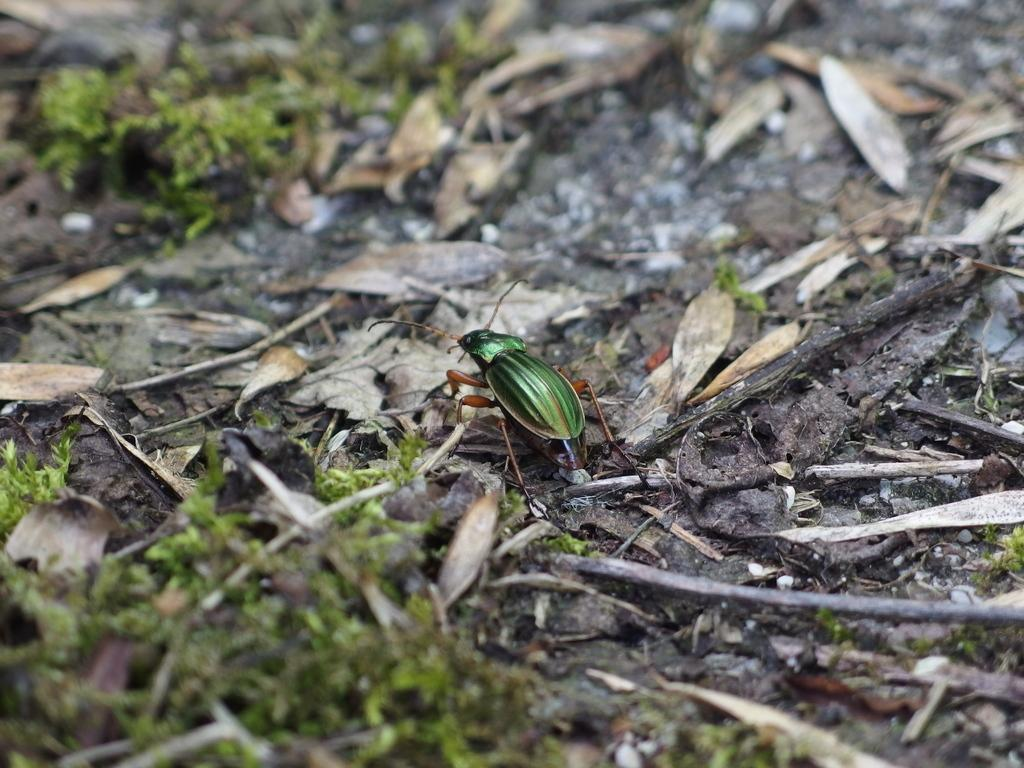What type of creature can be seen on the leaves in the image? There is an insect on the leaves in the image. What is the condition of the leaves in the image? The leaves are on the ground in the image. What other objects can be seen on the ground in the image? There are sticks and grass on the ground in the image. Reasoning: Let'g: Let's think step by step in order to produce the conversation. We start by identifying the main subject in the image, which is the insect on the leaves. Then, we describe the condition of the leaves, noting that they are on the ground. Finally, we expand the conversation to include other objects on the ground, such as sticks and grass. Each question is designed to elicit a specific detail about the image that is known from the provided facts. Absurd Question/Answer: What type of tomatoes can be seen growing in the image? There are no tomatoes present in the image; it features an insect on leaves, sticks, and grass on the ground. What time of day is depicted in the image? The time of day cannot be determined from the image, as there are no specific clues or indicators present. What type of volleyball can be seen in the image? There is no volleyball present in the image; it features an insect on leaves, sticks, and grass on the ground. 